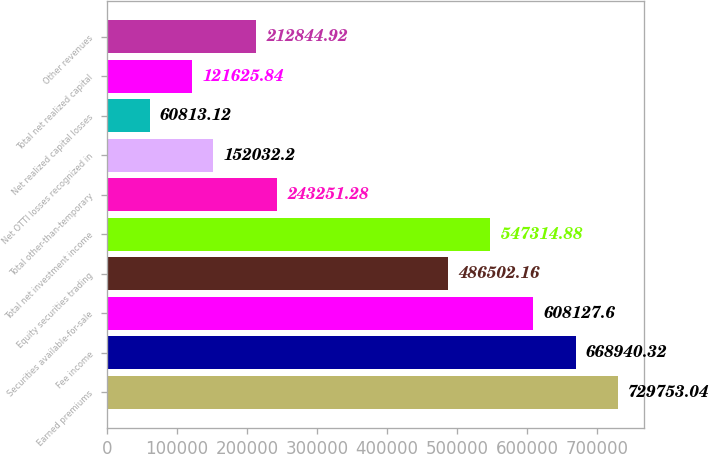Convert chart. <chart><loc_0><loc_0><loc_500><loc_500><bar_chart><fcel>Earned premiums<fcel>Fee income<fcel>Securities available-for-sale<fcel>Equity securities trading<fcel>Total net investment income<fcel>Total other-than-temporary<fcel>Net OTTI losses recognized in<fcel>Net realized capital losses<fcel>Total net realized capital<fcel>Other revenues<nl><fcel>729753<fcel>668940<fcel>608128<fcel>486502<fcel>547315<fcel>243251<fcel>152032<fcel>60813.1<fcel>121626<fcel>212845<nl></chart> 